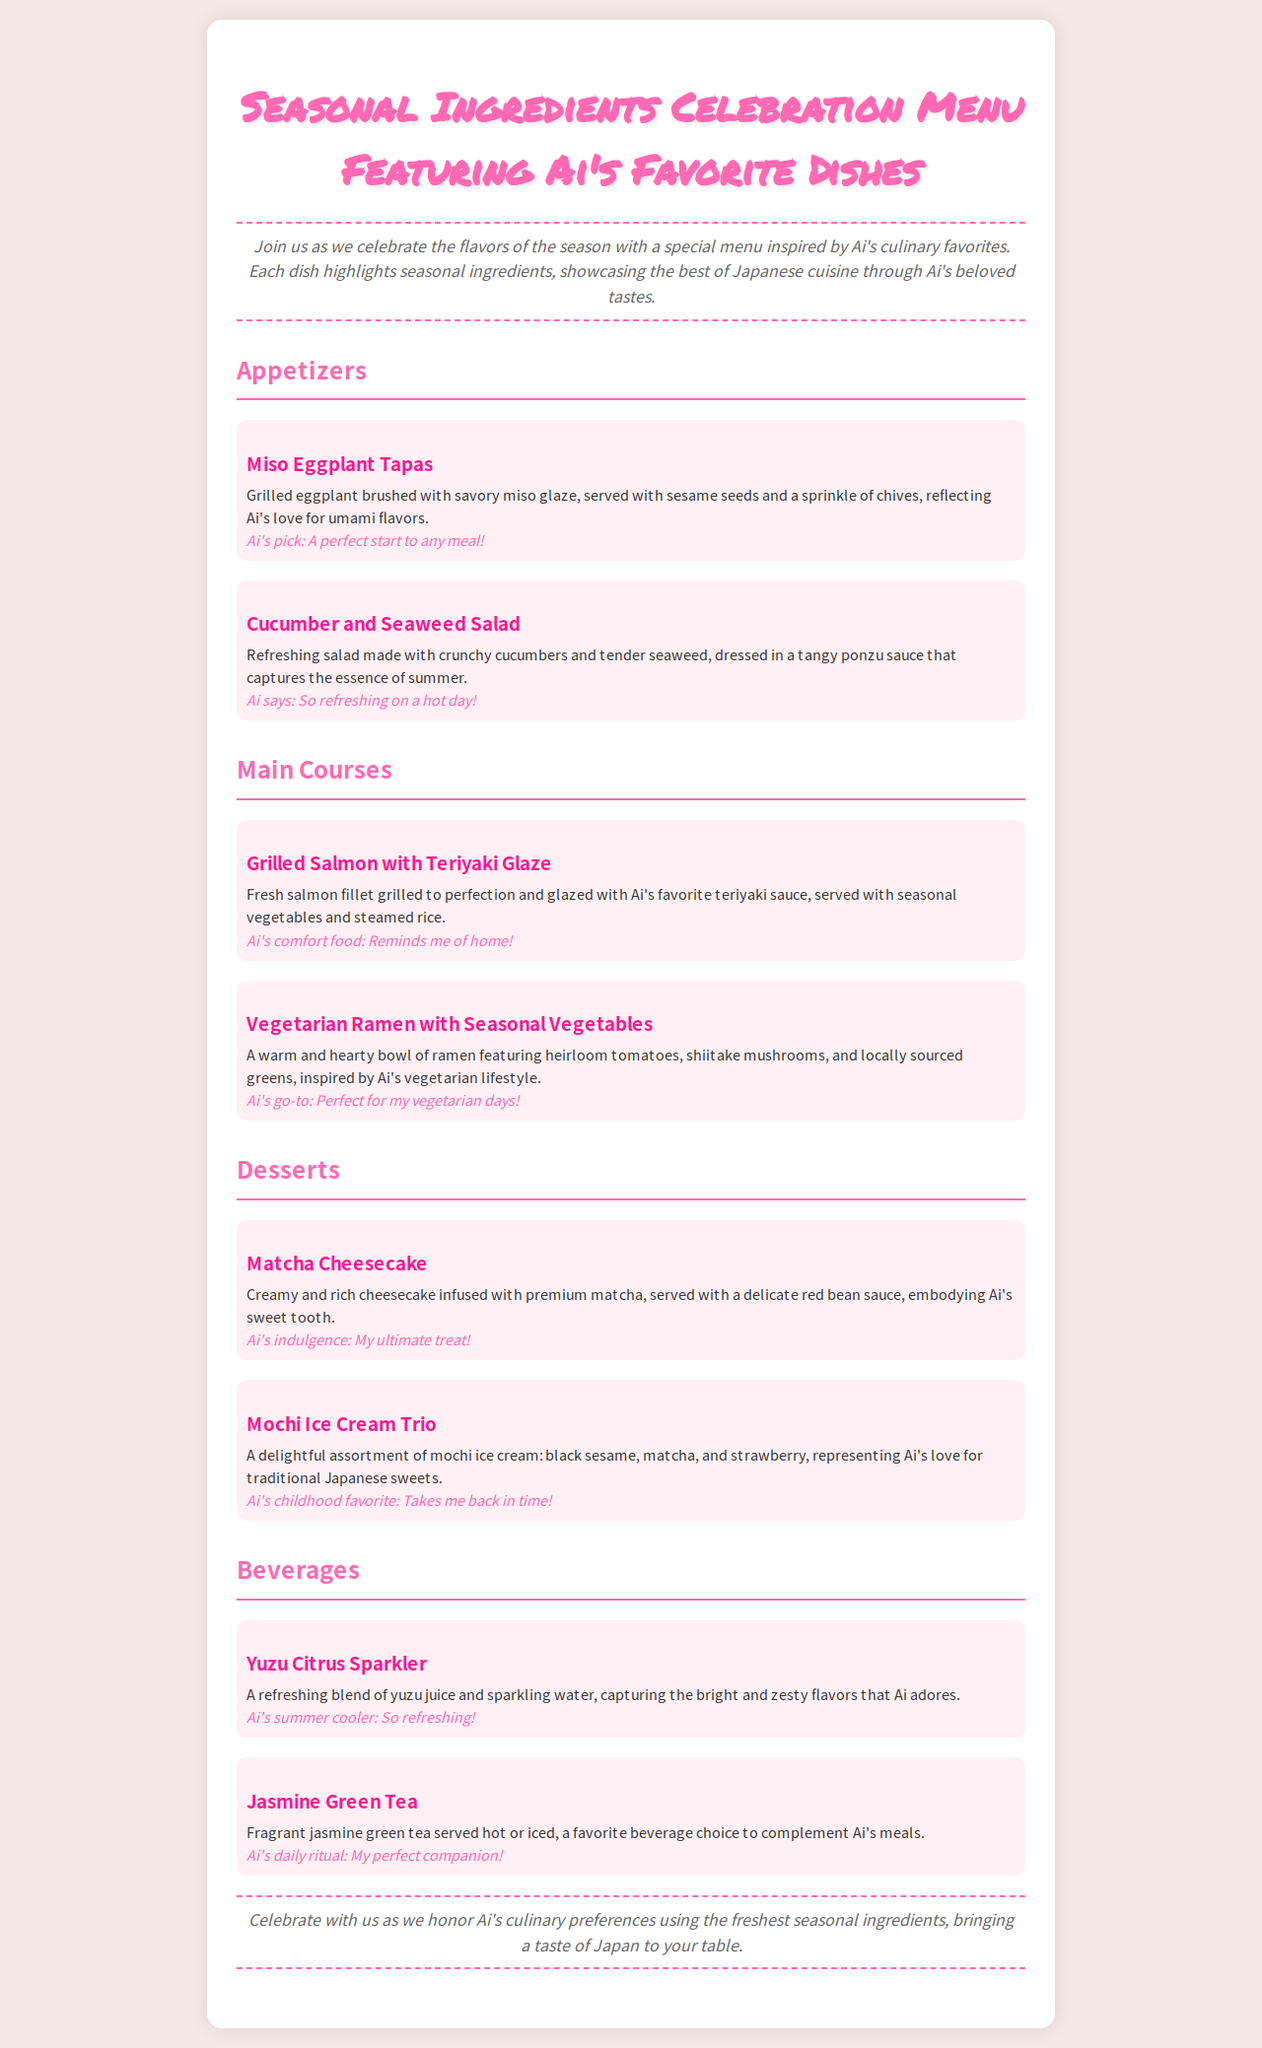what is the title of the menu? The title of the menu is stated at the top of the document, which showcases the seasonal ingredients and Ai's favorite dishes.
Answer: Seasonal Ingredients Celebration Menu Featuring Ai's Favorite Dishes what is one of Ai's favorite appetizers? The document lists several appetizers, including one specifically highlighted as Ai's pick, known for its umami flavors.
Answer: Miso Eggplant Tapas how many main courses are there? The number of main courses is indicated in the document, where it lists the different dishes under that section.
Answer: 2 what is Ai's comfort food? The menu mentions a specific main course that Ai describes as her comfort food, reflecting her personal taste.
Answer: Grilled Salmon with Teriyaki Glaze which dessert features matcha? The dessert section lists different options, and one of them prominently includes matcha as an ingredient.
Answer: Matcha Cheesecake what is Ai's childhood favorite dessert? The document indicates that one dessert is linked to Ai's childhood memories, making it her favorite.
Answer: Mochi Ice Cream Trio what type of beverage is served hot or iced? The beverages section specifies a type of tea that can be enjoyed in both hot and cold forms.
Answer: Jasmine Green Tea which salad captures the essence of summer? Among the appetizers, there is a salad that is specifically described to embody the summer season.
Answer: Cucumber and Seaweed Salad what is the flavor of Ai's favorite summer cooler? The document describes a beverage that offers refreshing and zesty flavors, which are Ai's preference for summer.
Answer: Yuzu Citrus Sparkler 